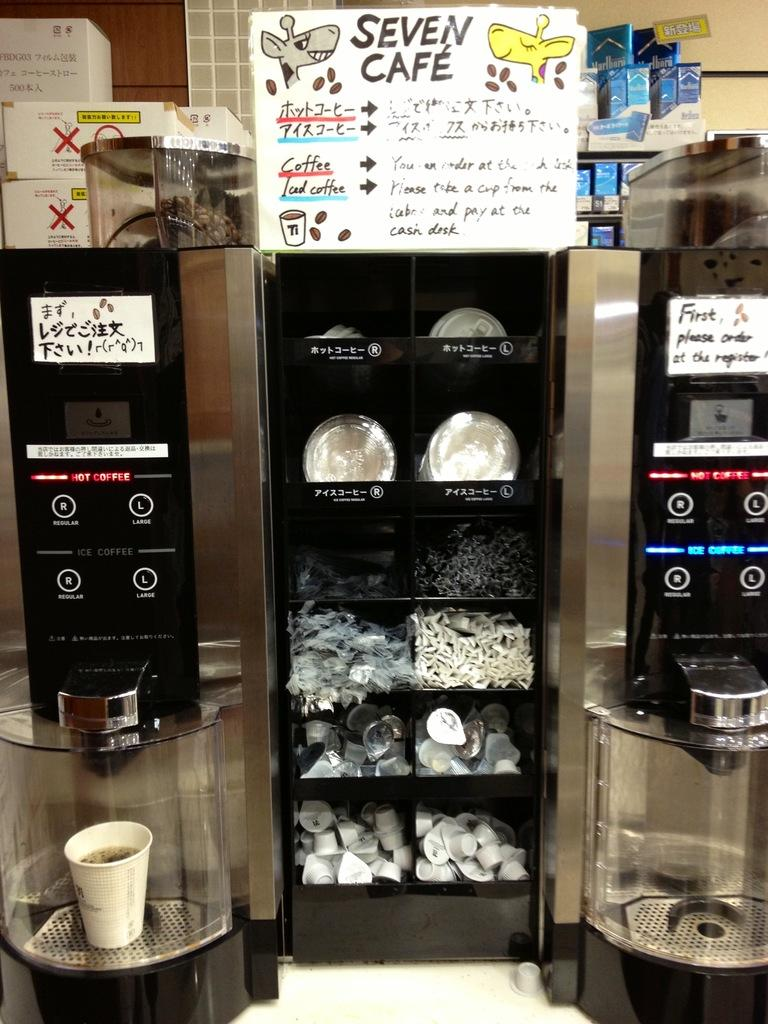<image>
Give a short and clear explanation of the subsequent image. A coffee dispenser filled with coffee items and coffee machines with a poster that says Seven Cafe. 